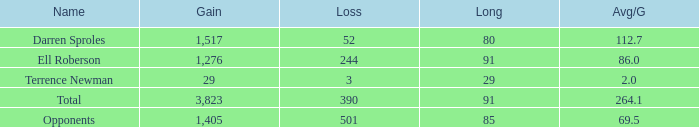When the Gain is 29, and the average per game is 2, and the player lost less than 390 yards, what's the sum of the Long yards? None. 